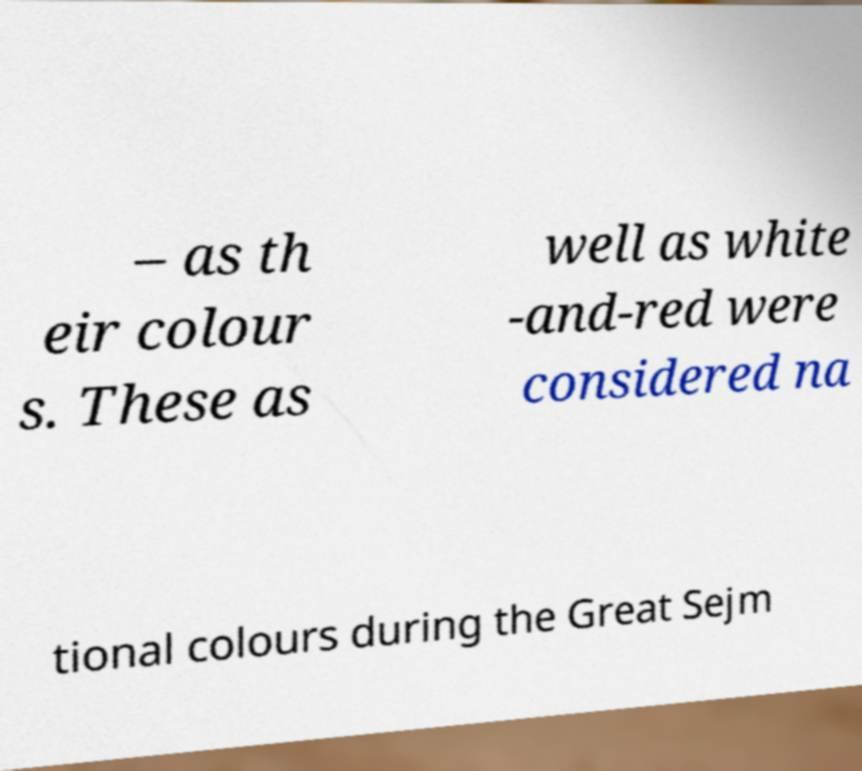I need the written content from this picture converted into text. Can you do that? – as th eir colour s. These as well as white -and-red were considered na tional colours during the Great Sejm 